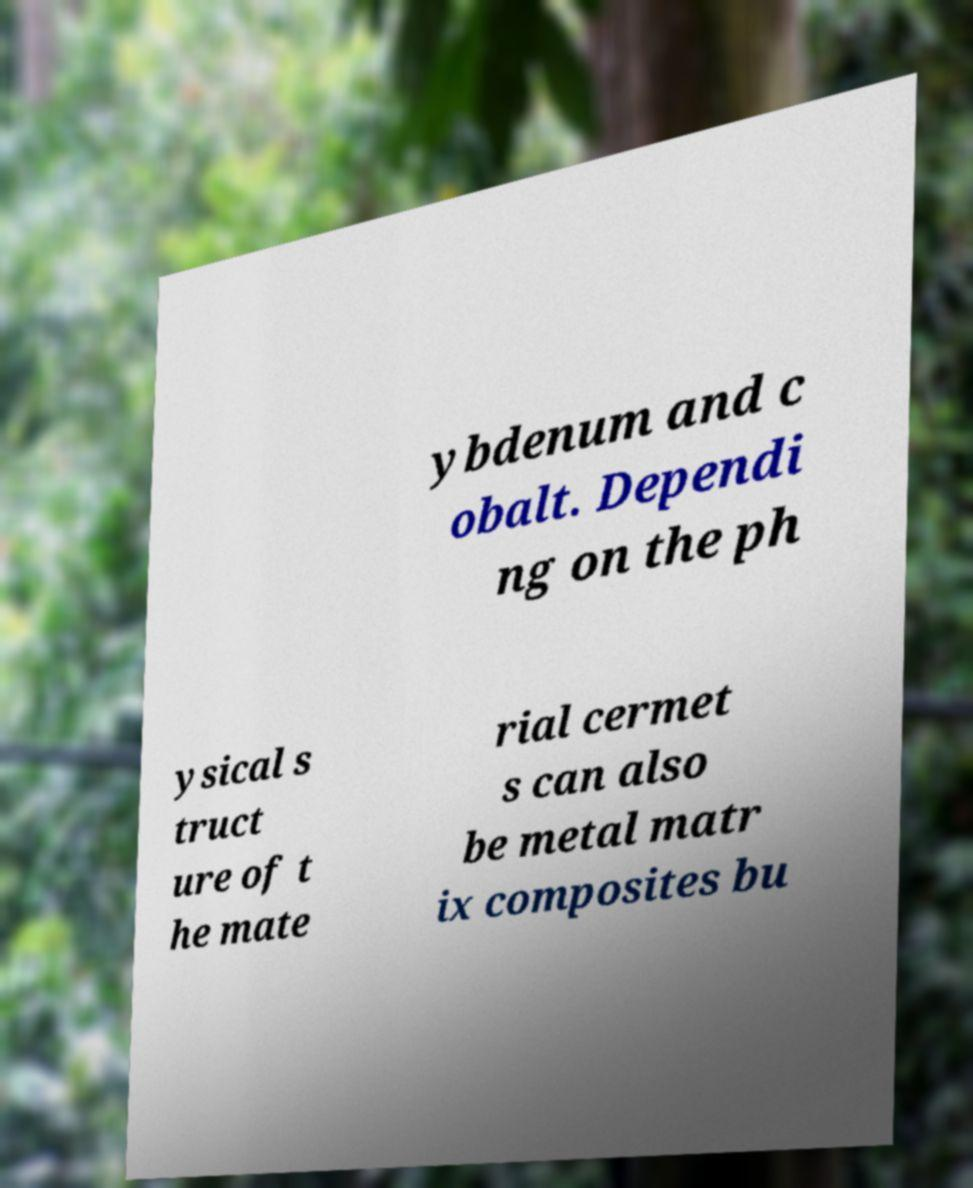Can you read and provide the text displayed in the image?This photo seems to have some interesting text. Can you extract and type it out for me? ybdenum and c obalt. Dependi ng on the ph ysical s truct ure of t he mate rial cermet s can also be metal matr ix composites bu 